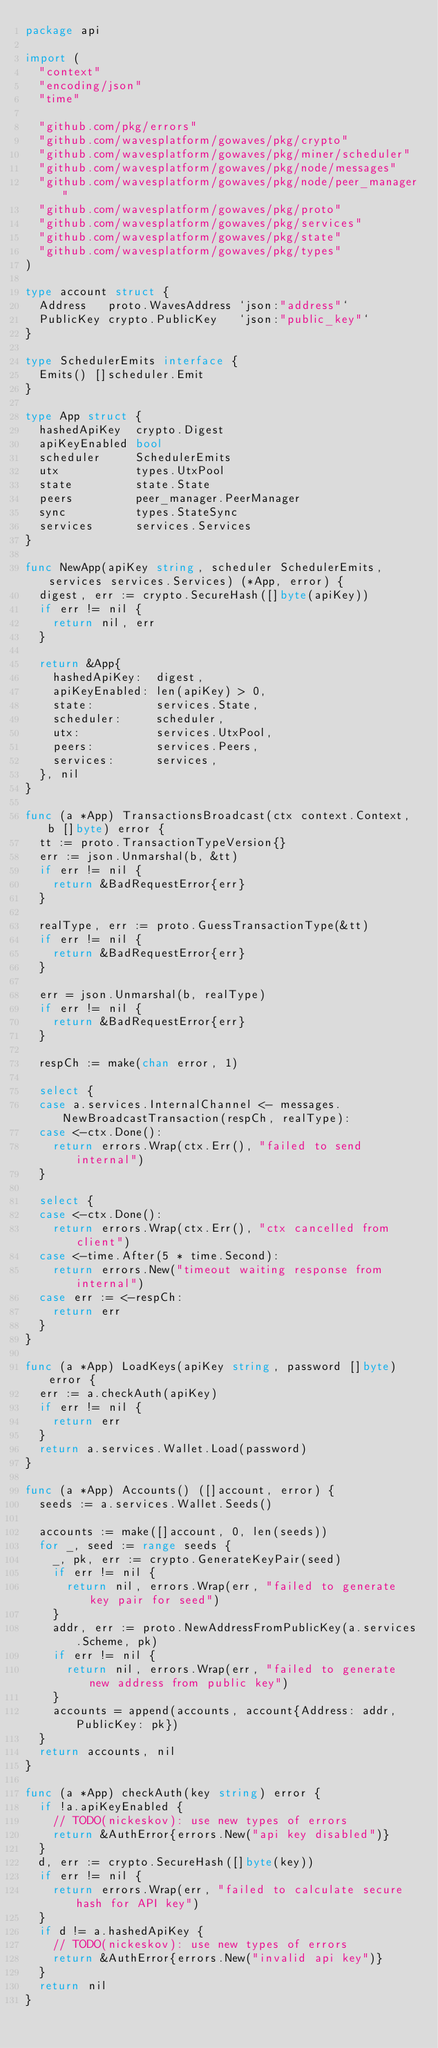<code> <loc_0><loc_0><loc_500><loc_500><_Go_>package api

import (
	"context"
	"encoding/json"
	"time"

	"github.com/pkg/errors"
	"github.com/wavesplatform/gowaves/pkg/crypto"
	"github.com/wavesplatform/gowaves/pkg/miner/scheduler"
	"github.com/wavesplatform/gowaves/pkg/node/messages"
	"github.com/wavesplatform/gowaves/pkg/node/peer_manager"
	"github.com/wavesplatform/gowaves/pkg/proto"
	"github.com/wavesplatform/gowaves/pkg/services"
	"github.com/wavesplatform/gowaves/pkg/state"
	"github.com/wavesplatform/gowaves/pkg/types"
)

type account struct {
	Address   proto.WavesAddress `json:"address"`
	PublicKey crypto.PublicKey   `json:"public_key"`
}

type SchedulerEmits interface {
	Emits() []scheduler.Emit
}

type App struct {
	hashedApiKey  crypto.Digest
	apiKeyEnabled bool
	scheduler     SchedulerEmits
	utx           types.UtxPool
	state         state.State
	peers         peer_manager.PeerManager
	sync          types.StateSync
	services      services.Services
}

func NewApp(apiKey string, scheduler SchedulerEmits, services services.Services) (*App, error) {
	digest, err := crypto.SecureHash([]byte(apiKey))
	if err != nil {
		return nil, err
	}

	return &App{
		hashedApiKey:  digest,
		apiKeyEnabled: len(apiKey) > 0,
		state:         services.State,
		scheduler:     scheduler,
		utx:           services.UtxPool,
		peers:         services.Peers,
		services:      services,
	}, nil
}

func (a *App) TransactionsBroadcast(ctx context.Context, b []byte) error {
	tt := proto.TransactionTypeVersion{}
	err := json.Unmarshal(b, &tt)
	if err != nil {
		return &BadRequestError{err}
	}

	realType, err := proto.GuessTransactionType(&tt)
	if err != nil {
		return &BadRequestError{err}
	}

	err = json.Unmarshal(b, realType)
	if err != nil {
		return &BadRequestError{err}
	}

	respCh := make(chan error, 1)

	select {
	case a.services.InternalChannel <- messages.NewBroadcastTransaction(respCh, realType):
	case <-ctx.Done():
		return errors.Wrap(ctx.Err(), "failed to send internal")
	}

	select {
	case <-ctx.Done():
		return errors.Wrap(ctx.Err(), "ctx cancelled from client")
	case <-time.After(5 * time.Second):
		return errors.New("timeout waiting response from internal")
	case err := <-respCh:
		return err
	}
}

func (a *App) LoadKeys(apiKey string, password []byte) error {
	err := a.checkAuth(apiKey)
	if err != nil {
		return err
	}
	return a.services.Wallet.Load(password)
}

func (a *App) Accounts() ([]account, error) {
	seeds := a.services.Wallet.Seeds()

	accounts := make([]account, 0, len(seeds))
	for _, seed := range seeds {
		_, pk, err := crypto.GenerateKeyPair(seed)
		if err != nil {
			return nil, errors.Wrap(err, "failed to generate key pair for seed")
		}
		addr, err := proto.NewAddressFromPublicKey(a.services.Scheme, pk)
		if err != nil {
			return nil, errors.Wrap(err, "failed to generate new address from public key")
		}
		accounts = append(accounts, account{Address: addr, PublicKey: pk})
	}
	return accounts, nil
}

func (a *App) checkAuth(key string) error {
	if !a.apiKeyEnabled {
		// TODO(nickeskov): use new types of errors
		return &AuthError{errors.New("api key disabled")}
	}
	d, err := crypto.SecureHash([]byte(key))
	if err != nil {
		return errors.Wrap(err, "failed to calculate secure hash for API key")
	}
	if d != a.hashedApiKey {
		// TODO(nickeskov): use new types of errors
		return &AuthError{errors.New("invalid api key")}
	}
	return nil
}
</code> 